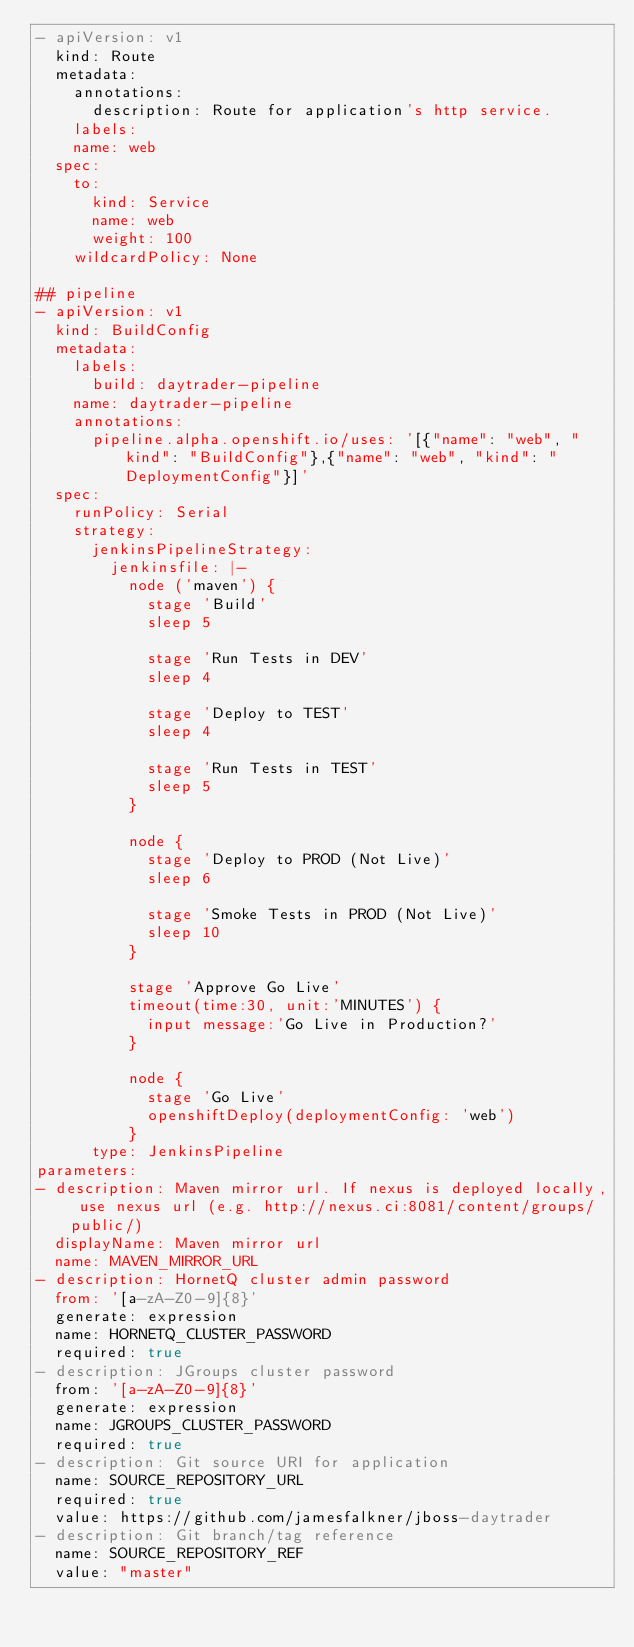<code> <loc_0><loc_0><loc_500><loc_500><_YAML_>- apiVersion: v1
  kind: Route
  metadata:
    annotations:
      description: Route for application's http service.
    labels:
    name: web
  spec:
    to:
      kind: Service
      name: web
      weight: 100
    wildcardPolicy: None

## pipeline
- apiVersion: v1
  kind: BuildConfig
  metadata:
    labels:
      build: daytrader-pipeline
    name: daytrader-pipeline
    annotations:
      pipeline.alpha.openshift.io/uses: '[{"name": "web", "kind": "BuildConfig"},{"name": "web", "kind": "DeploymentConfig"}]'
  spec:
    runPolicy: Serial
    strategy:
      jenkinsPipelineStrategy:
        jenkinsfile: |-
          node ('maven') {
            stage 'Build'
            sleep 5

            stage 'Run Tests in DEV'
            sleep 4

            stage 'Deploy to TEST'
            sleep 4

            stage 'Run Tests in TEST'
            sleep 5
          }

          node {
            stage 'Deploy to PROD (Not Live)'
            sleep 6

            stage 'Smoke Tests in PROD (Not Live)'
            sleep 10
          }

          stage 'Approve Go Live'
          timeout(time:30, unit:'MINUTES') {
            input message:'Go Live in Production?'
          }

          node {
            stage 'Go Live'
            openshiftDeploy(deploymentConfig: 'web')
          }
      type: JenkinsPipeline
parameters:
- description: Maven mirror url. If nexus is deployed locally, use nexus url (e.g. http://nexus.ci:8081/content/groups/public/)
  displayName: Maven mirror url
  name: MAVEN_MIRROR_URL
- description: HornetQ cluster admin password
  from: '[a-zA-Z0-9]{8}'
  generate: expression
  name: HORNETQ_CLUSTER_PASSWORD
  required: true
- description: JGroups cluster password
  from: '[a-zA-Z0-9]{8}'
  generate: expression
  name: JGROUPS_CLUSTER_PASSWORD
  required: true
- description: Git source URI for application
  name: SOURCE_REPOSITORY_URL
  required: true
  value: https://github.com/jamesfalkner/jboss-daytrader
- description: Git branch/tag reference
  name: SOURCE_REPOSITORY_REF
  value: "master"
</code> 